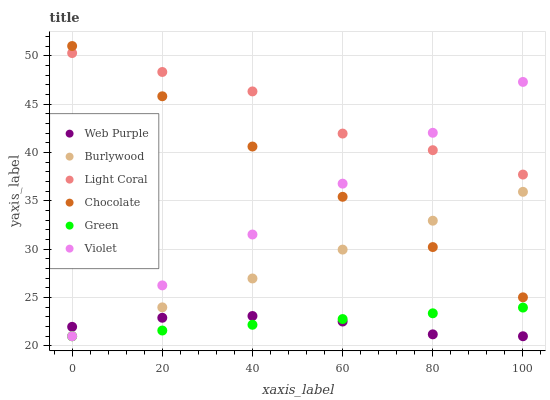Does Web Purple have the minimum area under the curve?
Answer yes or no. Yes. Does Light Coral have the maximum area under the curve?
Answer yes or no. Yes. Does Chocolate have the minimum area under the curve?
Answer yes or no. No. Does Chocolate have the maximum area under the curve?
Answer yes or no. No. Is Violet the smoothest?
Answer yes or no. Yes. Is Light Coral the roughest?
Answer yes or no. Yes. Is Chocolate the smoothest?
Answer yes or no. No. Is Chocolate the roughest?
Answer yes or no. No. Does Burlywood have the lowest value?
Answer yes or no. Yes. Does Chocolate have the lowest value?
Answer yes or no. No. Does Chocolate have the highest value?
Answer yes or no. Yes. Does Light Coral have the highest value?
Answer yes or no. No. Is Burlywood less than Light Coral?
Answer yes or no. Yes. Is Light Coral greater than Burlywood?
Answer yes or no. Yes. Does Violet intersect Green?
Answer yes or no. Yes. Is Violet less than Green?
Answer yes or no. No. Is Violet greater than Green?
Answer yes or no. No. Does Burlywood intersect Light Coral?
Answer yes or no. No. 